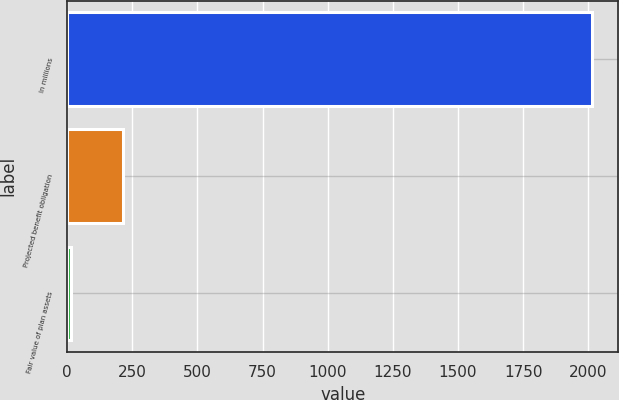Convert chart. <chart><loc_0><loc_0><loc_500><loc_500><bar_chart><fcel>In millions<fcel>Projected benefit obligation<fcel>Fair value of plan assets<nl><fcel>2015<fcel>216.44<fcel>16.6<nl></chart> 